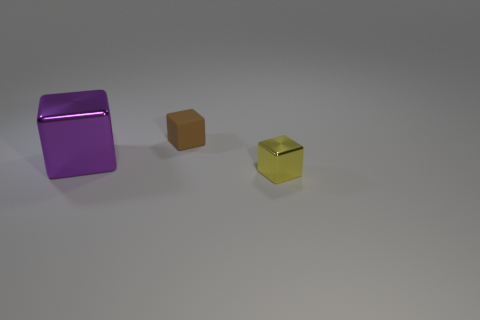Add 3 yellow cubes. How many objects exist? 6 Add 3 brown shiny cylinders. How many brown shiny cylinders exist? 3 Subtract 0 red spheres. How many objects are left? 3 Subtract all tiny objects. Subtract all brown blocks. How many objects are left? 0 Add 1 big purple metal cubes. How many big purple metal cubes are left? 2 